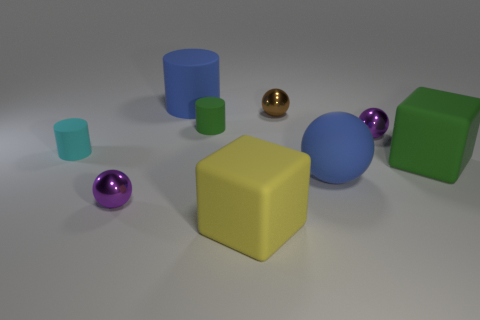Is there any other thing that is the same shape as the small green matte thing? Yes, there is a blue object which appears to be of a similar cylindrical shape as the small green matte object. 